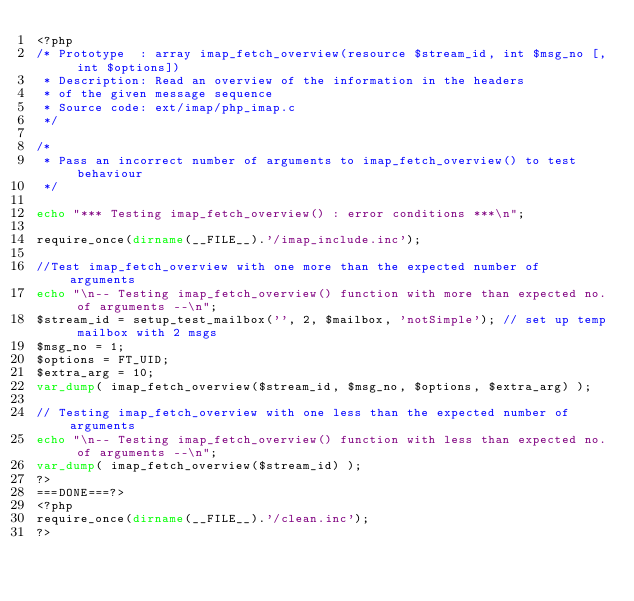Convert code to text. <code><loc_0><loc_0><loc_500><loc_500><_PHP_><?php
/* Prototype  : array imap_fetch_overview(resource $stream_id, int $msg_no [, int $options])
 * Description: Read an overview of the information in the headers 
 * of the given message sequence 
 * Source code: ext/imap/php_imap.c
 */

/*
 * Pass an incorrect number of arguments to imap_fetch_overview() to test behaviour
 */

echo "*** Testing imap_fetch_overview() : error conditions ***\n";

require_once(dirname(__FILE__).'/imap_include.inc');

//Test imap_fetch_overview with one more than the expected number of arguments
echo "\n-- Testing imap_fetch_overview() function with more than expected no. of arguments --\n";
$stream_id = setup_test_mailbox('', 2, $mailbox, 'notSimple'); // set up temp mailbox with 2 msgs
$msg_no = 1;
$options = FT_UID;
$extra_arg = 10;
var_dump( imap_fetch_overview($stream_id, $msg_no, $options, $extra_arg) );

// Testing imap_fetch_overview with one less than the expected number of arguments
echo "\n-- Testing imap_fetch_overview() function with less than expected no. of arguments --\n";
var_dump( imap_fetch_overview($stream_id) );
?>
===DONE===?>
<?php
require_once(dirname(__FILE__).'/clean.inc');
?></code> 